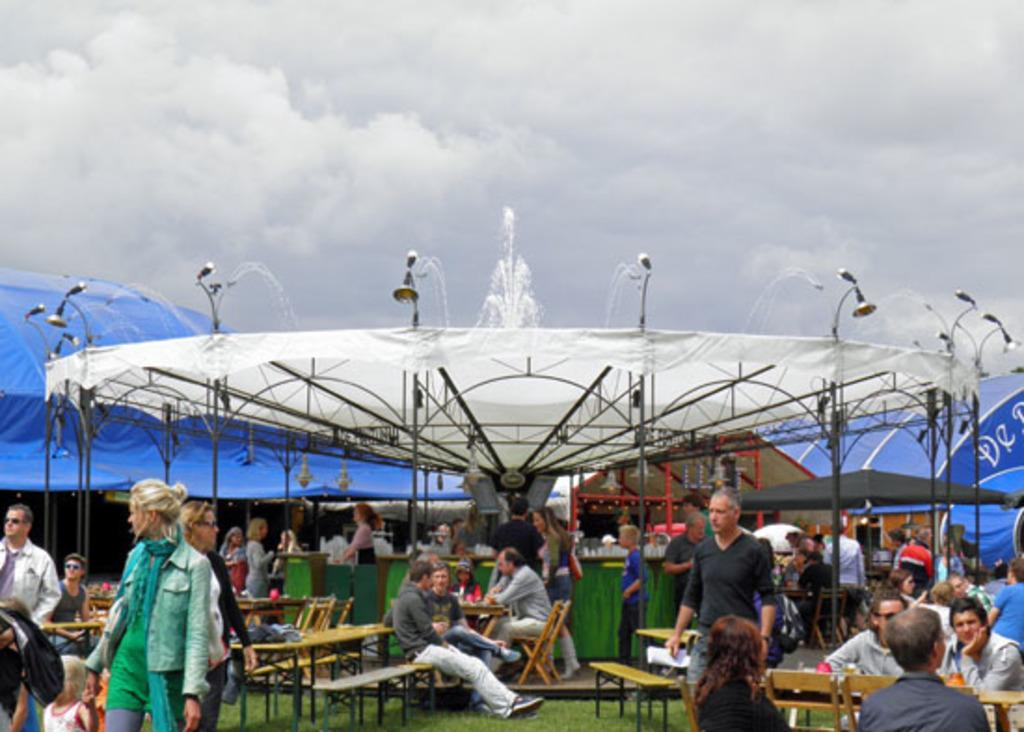What is the main focus of the image? There are people in the center of the image. What type of seating is present in the image? There are benches in the image. What type of structure can be seen in the image? There is a tent in the image. What is the water feature in the image? There is a fountain in the image. What can be seen in the background of the image? There are clouds in the background of the image. What type of arithmetic problem is being solved by the crowd in the image? There is no crowd or arithmetic problem present in the image. What type of screw is being used to hold the tent together in the image? There is no screw visible in the image; the tent is not being assembled or disassembled. 